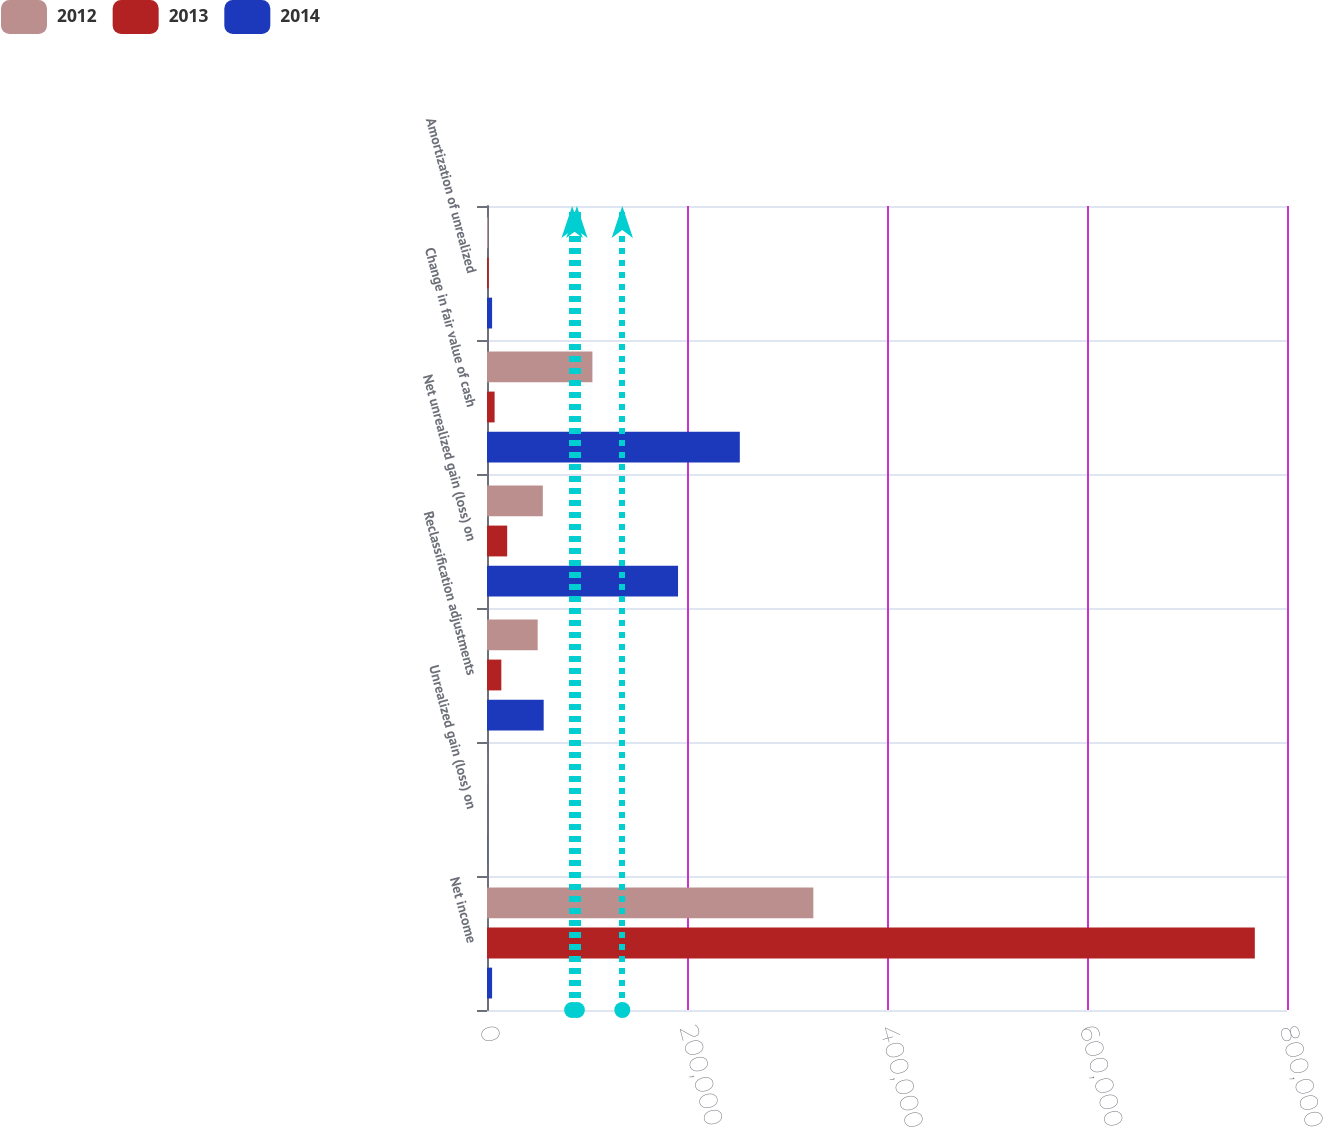<chart> <loc_0><loc_0><loc_500><loc_500><stacked_bar_chart><ecel><fcel>Net income<fcel>Unrealized gain (loss) on<fcel>Reclassification adjustments<fcel>Net unrealized gain (loss) on<fcel>Change in fair value of cash<fcel>Amortization of unrealized<nl><fcel>2012<fcel>326328<fcel>153<fcel>50682<fcel>55812<fcel>105414<fcel>1080<nl><fcel>2013<fcel>767823<fcel>73<fcel>14318<fcel>20183<fcel>7614<fcel>1749<nl><fcel>2014<fcel>5095<fcel>149<fcel>56683<fcel>191039<fcel>252817<fcel>5095<nl></chart> 